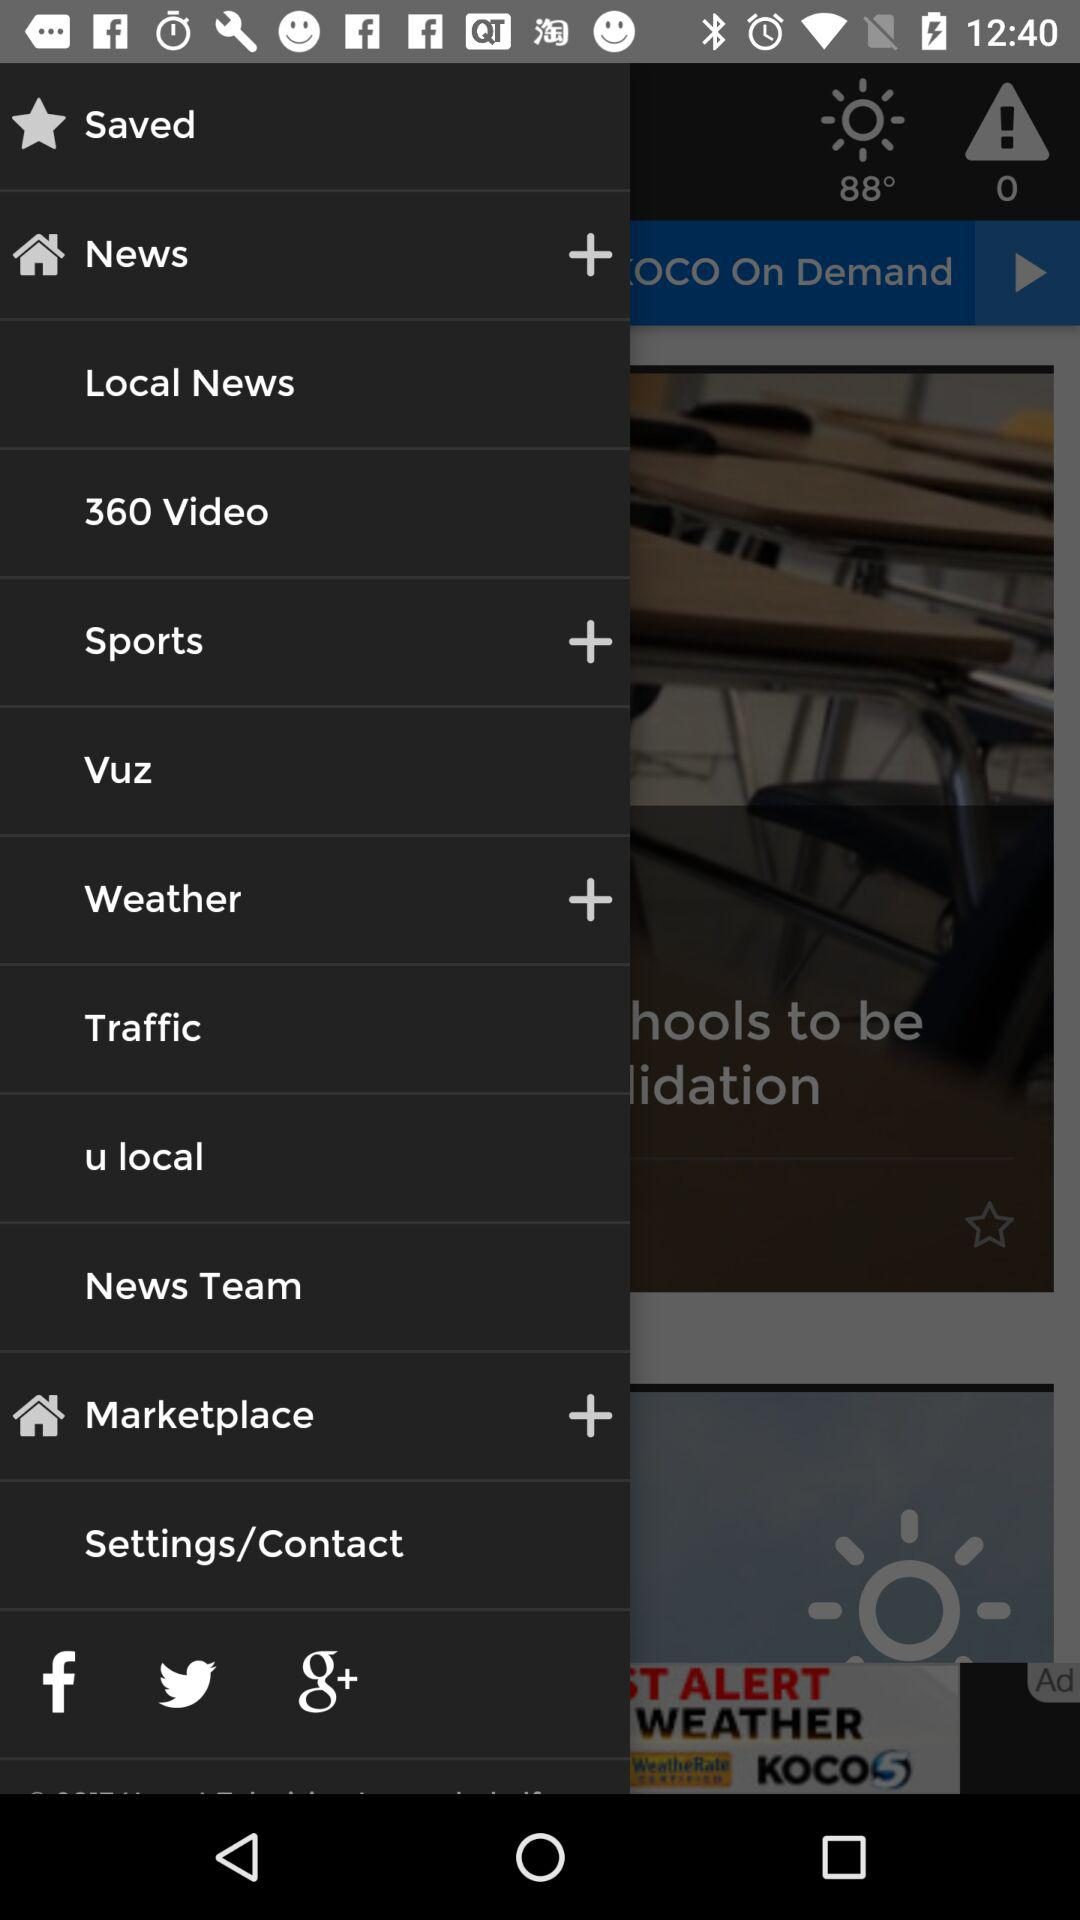What is the temperature? The temperature is 88 degrees. 